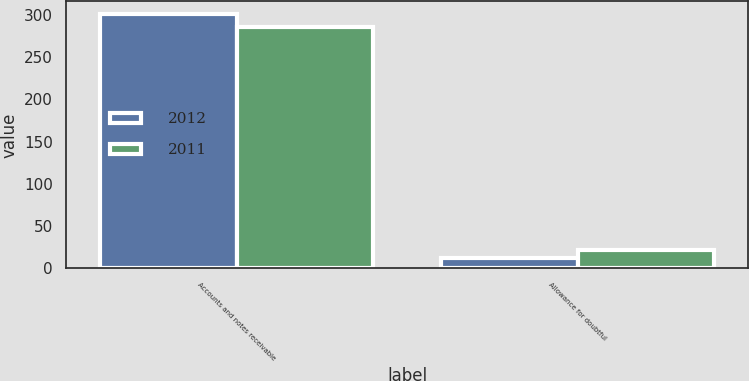<chart> <loc_0><loc_0><loc_500><loc_500><stacked_bar_chart><ecel><fcel>Accounts and notes receivable<fcel>Allowance for doubtful<nl><fcel>2012<fcel>301<fcel>12<nl><fcel>2011<fcel>286<fcel>22<nl></chart> 